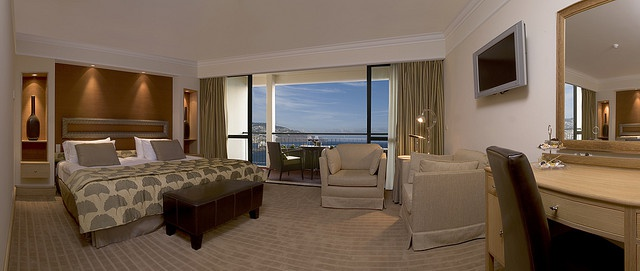Describe the objects in this image and their specific colors. I can see bed in gray and black tones, chair in gray tones, couch in gray and maroon tones, chair in gray, black, and maroon tones, and chair in gray, maroon, and black tones in this image. 